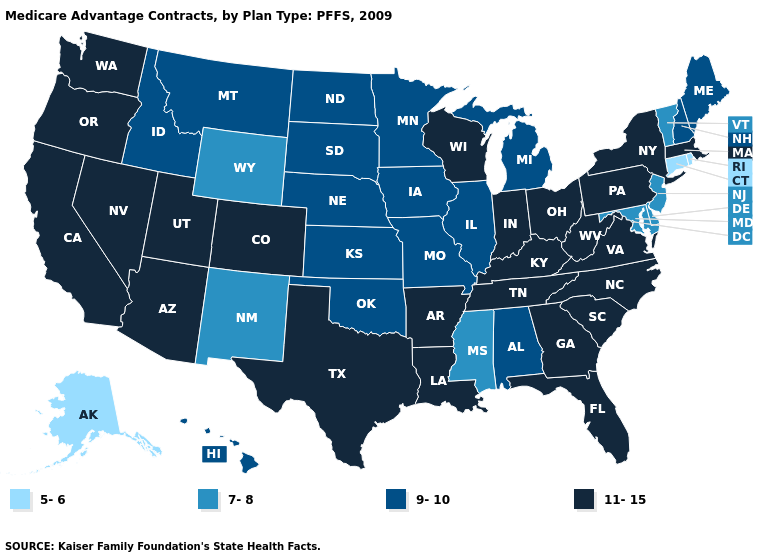Name the states that have a value in the range 5-6?
Give a very brief answer. Alaska, Connecticut, Rhode Island. Which states hav the highest value in the South?
Short answer required. Arkansas, Florida, Georgia, Kentucky, Louisiana, North Carolina, South Carolina, Tennessee, Texas, Virginia, West Virginia. What is the highest value in states that border Maine?
Keep it brief. 9-10. Name the states that have a value in the range 5-6?
Give a very brief answer. Alaska, Connecticut, Rhode Island. What is the highest value in the USA?
Write a very short answer. 11-15. Name the states that have a value in the range 7-8?
Write a very short answer. Delaware, Maryland, Mississippi, New Jersey, New Mexico, Vermont, Wyoming. Name the states that have a value in the range 5-6?
Quick response, please. Alaska, Connecticut, Rhode Island. What is the value of Texas?
Concise answer only. 11-15. Among the states that border Washington , which have the highest value?
Write a very short answer. Oregon. Is the legend a continuous bar?
Concise answer only. No. Does the first symbol in the legend represent the smallest category?
Write a very short answer. Yes. What is the value of West Virginia?
Keep it brief. 11-15. Does Indiana have the lowest value in the MidWest?
Quick response, please. No. How many symbols are there in the legend?
Give a very brief answer. 4. Name the states that have a value in the range 7-8?
Short answer required. Delaware, Maryland, Mississippi, New Jersey, New Mexico, Vermont, Wyoming. 